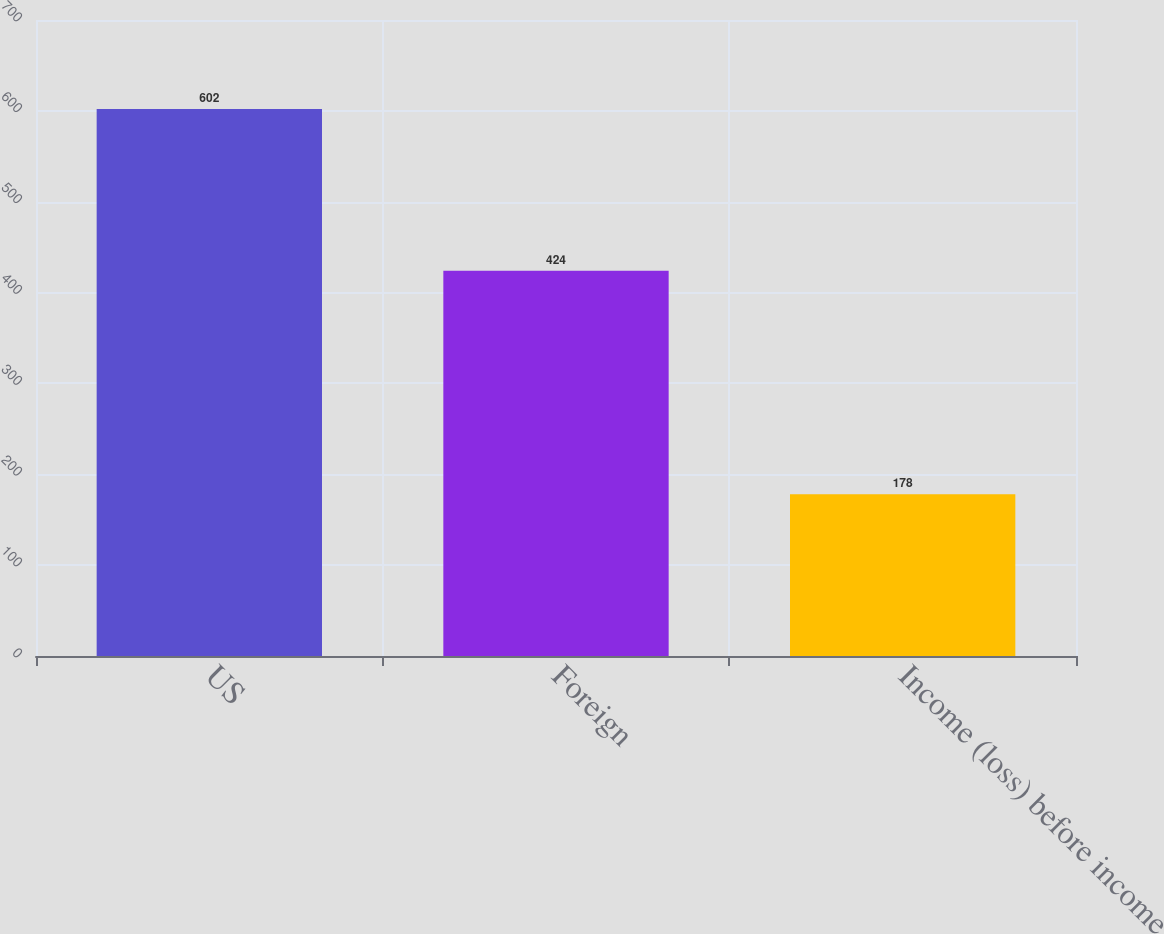<chart> <loc_0><loc_0><loc_500><loc_500><bar_chart><fcel>US<fcel>Foreign<fcel>Income (loss) before income<nl><fcel>602<fcel>424<fcel>178<nl></chart> 